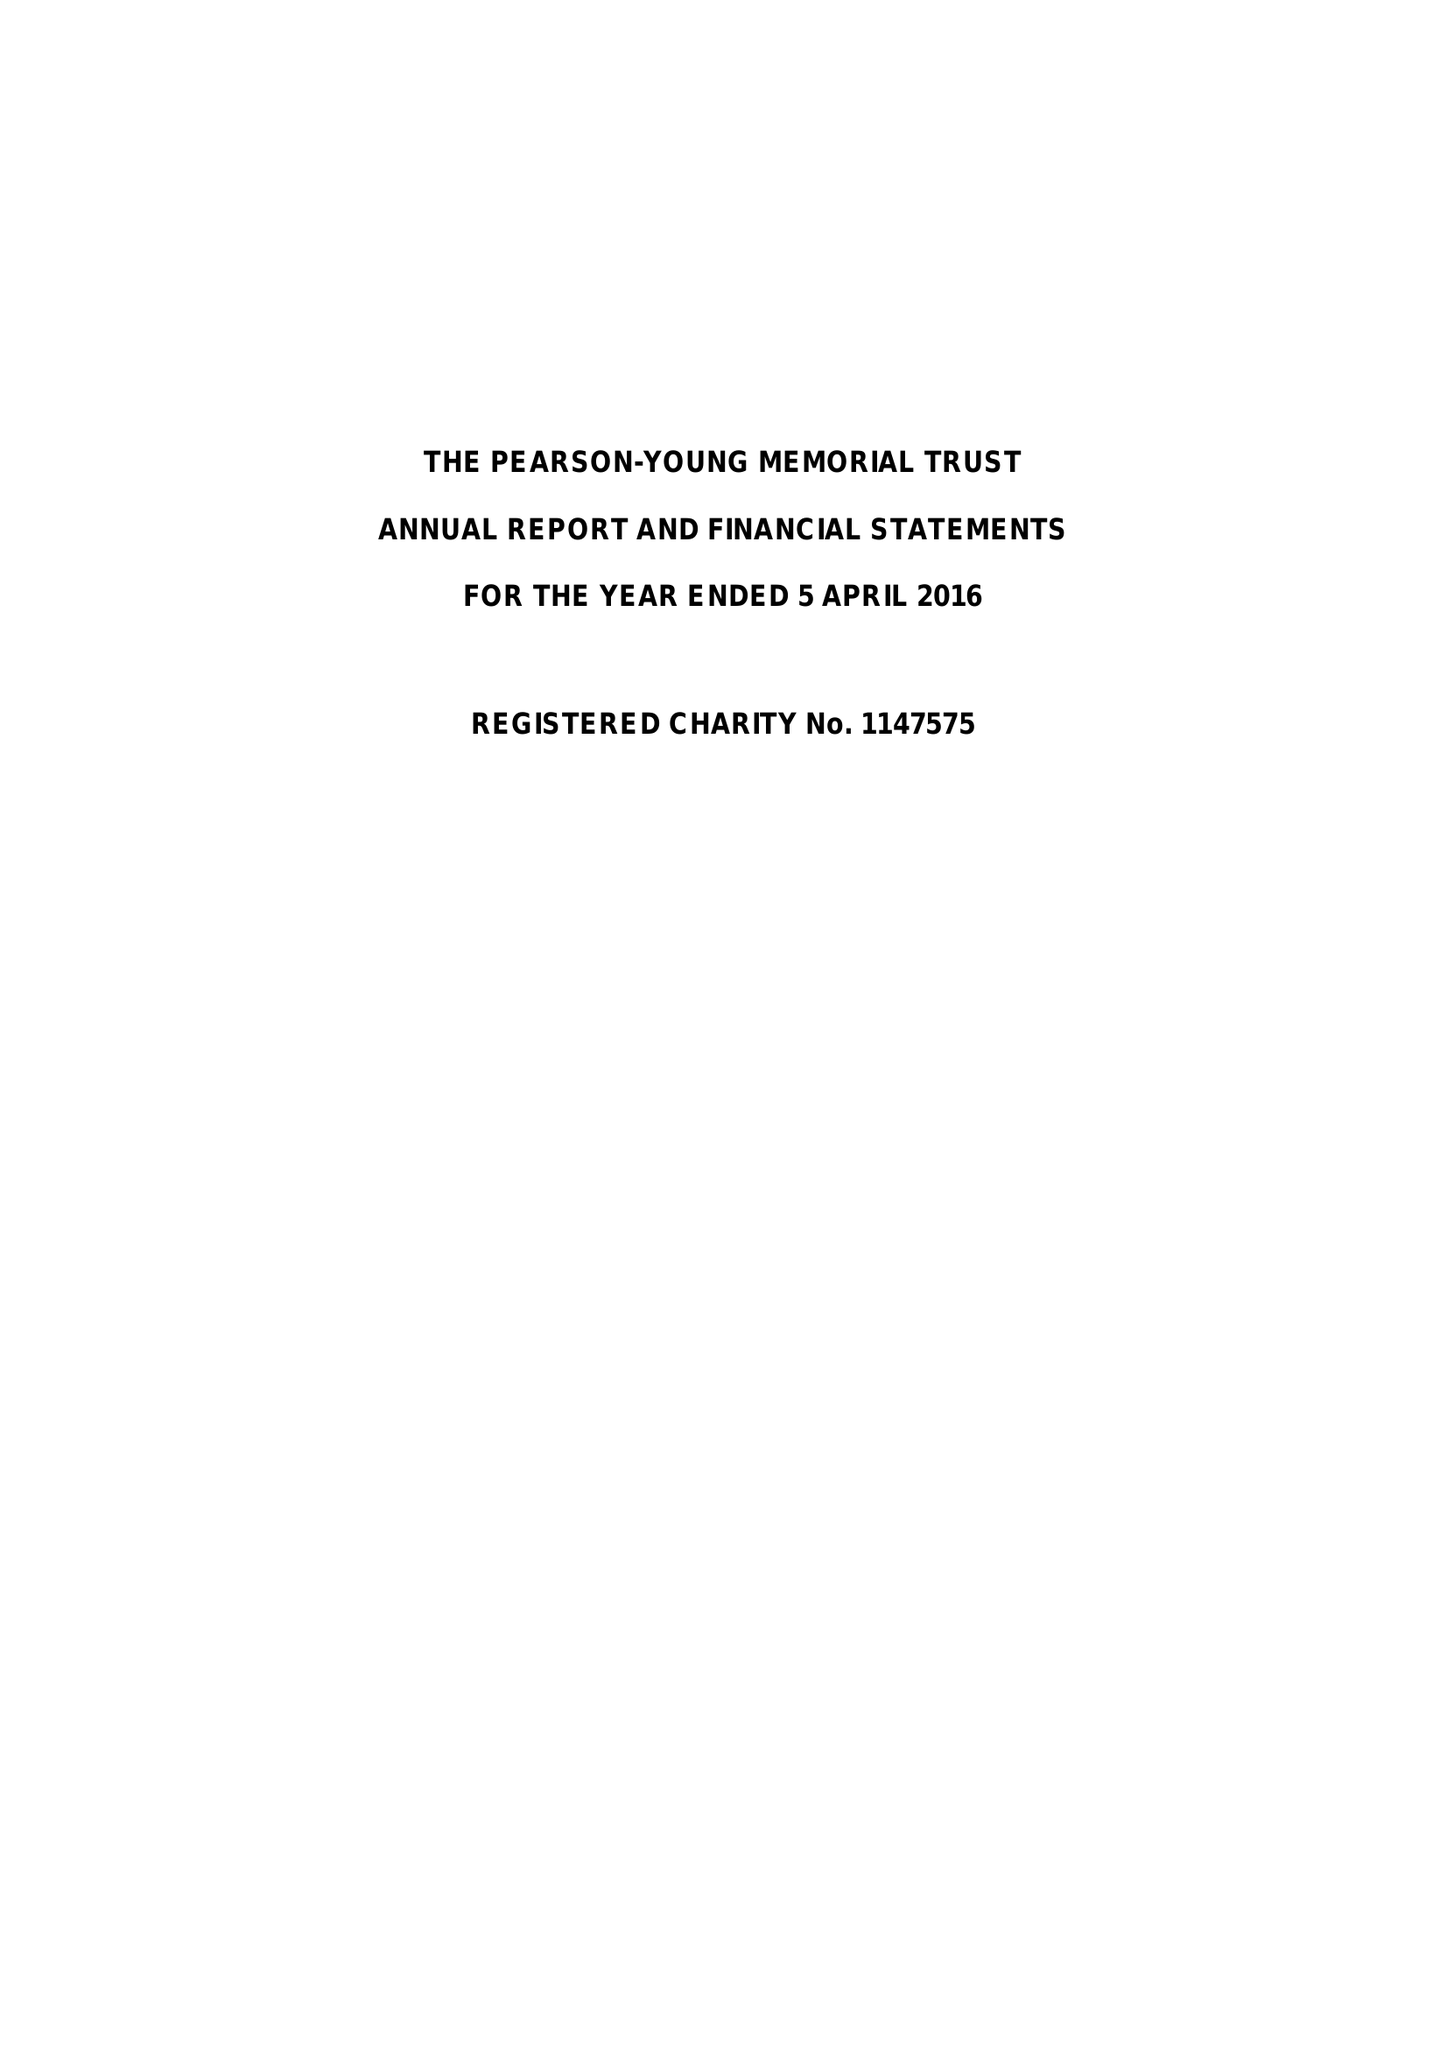What is the value for the address__street_line?
Answer the question using a single word or phrase. 50 BROADWAY 